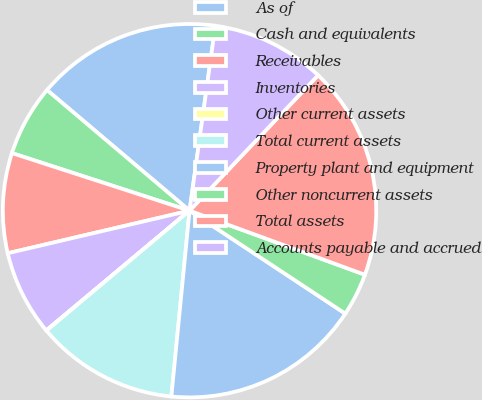<chart> <loc_0><loc_0><loc_500><loc_500><pie_chart><fcel>As of<fcel>Cash and equivalents<fcel>Receivables<fcel>Inventories<fcel>Other current assets<fcel>Total current assets<fcel>Property plant and equipment<fcel>Other noncurrent assets<fcel>Total assets<fcel>Accounts payable and accrued<nl><fcel>16.03%<fcel>6.19%<fcel>8.65%<fcel>7.42%<fcel>0.03%<fcel>12.34%<fcel>17.26%<fcel>3.72%<fcel>18.49%<fcel>9.88%<nl></chart> 